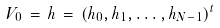<formula> <loc_0><loc_0><loc_500><loc_500>V _ { 0 } \, = \, h \, = \, ( h _ { 0 } , h _ { 1 } , \dots , h _ { N - 1 } ) ^ { t }</formula> 